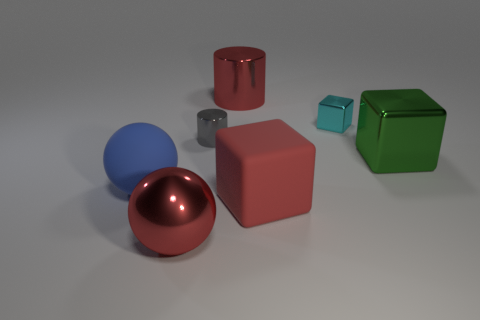Subtract all big red cubes. How many cubes are left? 2 Add 3 gray metal objects. How many objects exist? 10 Subtract all cylinders. How many objects are left? 5 Add 3 small metal things. How many small metal things are left? 5 Add 2 small blue rubber things. How many small blue rubber things exist? 2 Subtract 0 yellow spheres. How many objects are left? 7 Subtract all cyan metallic cubes. Subtract all matte cubes. How many objects are left? 5 